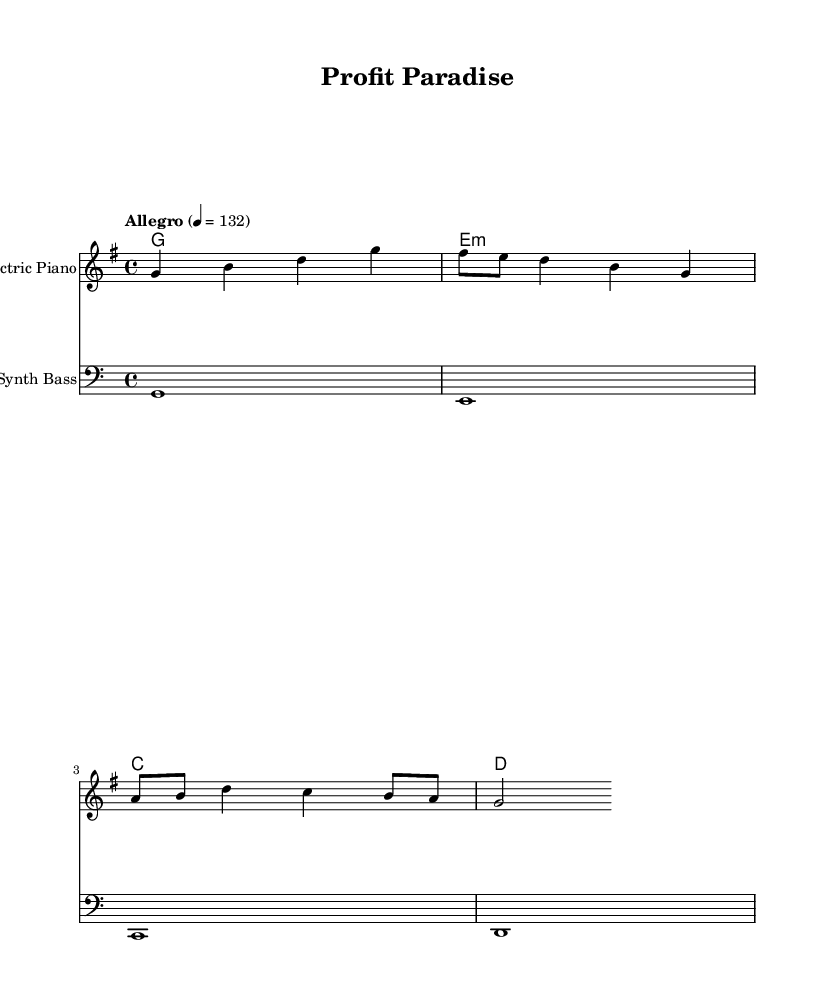What is the key signature of this music? The key signature is G major since it has one sharp (F sharp), which is indicated at the beginning of the staff.
Answer: G major What is the time signature of the piece? The time signature is 4/4, which is shown at the beginning of the sheet music. This means there are four beats in each measure.
Answer: 4/4 What is the tempo marking of the music? The tempo marking is "Allegro," and it specifies a speed of 132 beats per minute, which is noted in the tempo indication in the score.
Answer: Allegro How many measures are in the melody? Counting the distinct sets of four beats, the melody consists of four measures (or bars). Each measure is separated visually by vertical lines in the score.
Answer: 4 What type of harmonies are used in this piece? The harmonies follow a chord progression of G major, E minor, C major, and D major, as indicated in the chord names section. This analysis considers the named chords for each measure.
Answer: G major, E minor, C major, D major What instrument is playing the melody? The melody is designated to be played by an Electric Piano, which is specified in the staff label at the top of the melody staff.
Answer: Electric Piano What is the lowest note played in the bass line? The lowest note in the bass line is G, which is the first note indicated with the bass clef marking at the beginning of the staff.
Answer: G 